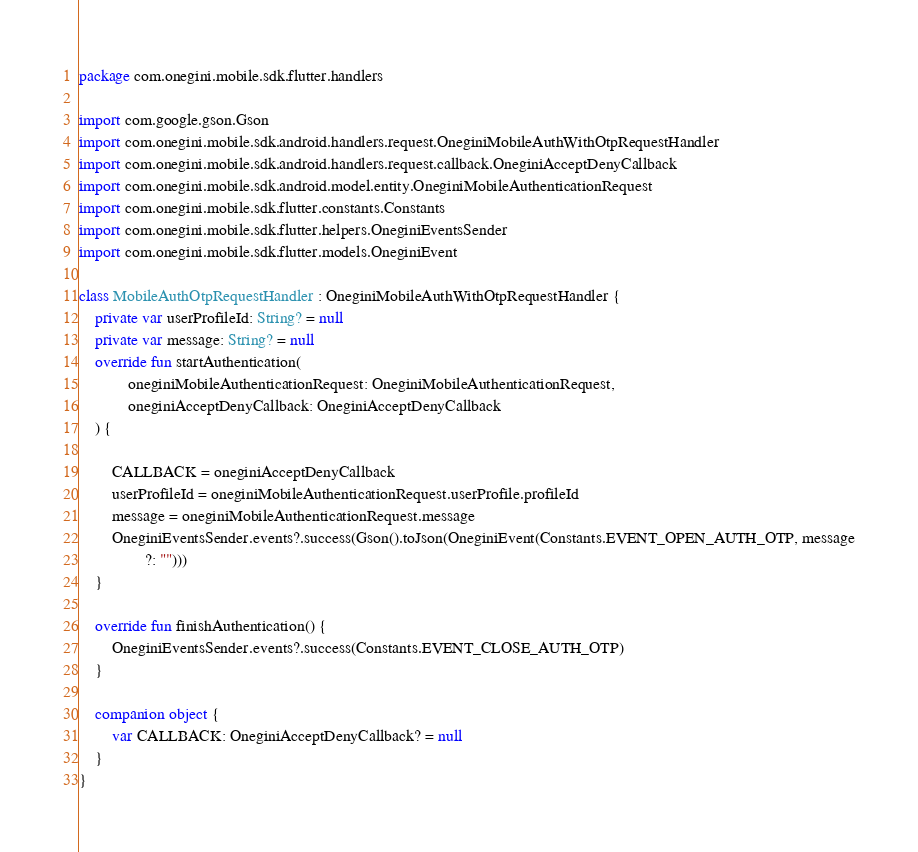Convert code to text. <code><loc_0><loc_0><loc_500><loc_500><_Kotlin_>package com.onegini.mobile.sdk.flutter.handlers

import com.google.gson.Gson
import com.onegini.mobile.sdk.android.handlers.request.OneginiMobileAuthWithOtpRequestHandler
import com.onegini.mobile.sdk.android.handlers.request.callback.OneginiAcceptDenyCallback
import com.onegini.mobile.sdk.android.model.entity.OneginiMobileAuthenticationRequest
import com.onegini.mobile.sdk.flutter.constants.Constants
import com.onegini.mobile.sdk.flutter.helpers.OneginiEventsSender
import com.onegini.mobile.sdk.flutter.models.OneginiEvent

class MobileAuthOtpRequestHandler : OneginiMobileAuthWithOtpRequestHandler {
    private var userProfileId: String? = null
    private var message: String? = null
    override fun startAuthentication(
            oneginiMobileAuthenticationRequest: OneginiMobileAuthenticationRequest,
            oneginiAcceptDenyCallback: OneginiAcceptDenyCallback
    ) {

        CALLBACK = oneginiAcceptDenyCallback
        userProfileId = oneginiMobileAuthenticationRequest.userProfile.profileId
        message = oneginiMobileAuthenticationRequest.message
        OneginiEventsSender.events?.success(Gson().toJson(OneginiEvent(Constants.EVENT_OPEN_AUTH_OTP, message
                ?: "")))
    }

    override fun finishAuthentication() {
        OneginiEventsSender.events?.success(Constants.EVENT_CLOSE_AUTH_OTP)
    }

    companion object {
        var CALLBACK: OneginiAcceptDenyCallback? = null
    }
}
</code> 